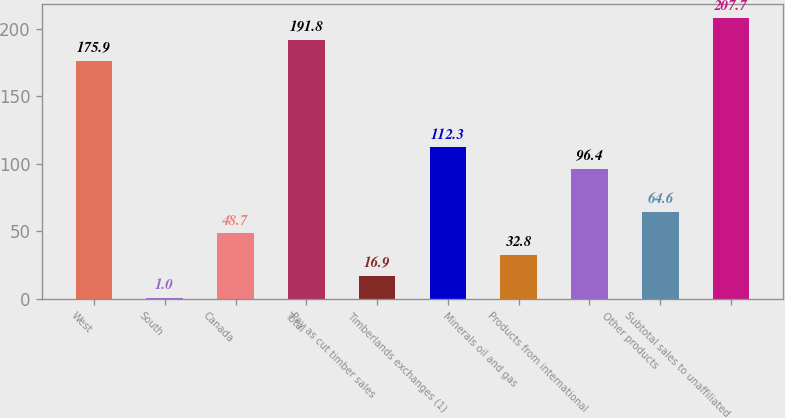<chart> <loc_0><loc_0><loc_500><loc_500><bar_chart><fcel>West<fcel>South<fcel>Canada<fcel>Total<fcel>Pay as cut timber sales<fcel>Timberlands exchanges (1)<fcel>Minerals oil and gas<fcel>Products from international<fcel>Other products<fcel>Subtotal sales to unaffiliated<nl><fcel>175.9<fcel>1<fcel>48.7<fcel>191.8<fcel>16.9<fcel>112.3<fcel>32.8<fcel>96.4<fcel>64.6<fcel>207.7<nl></chart> 